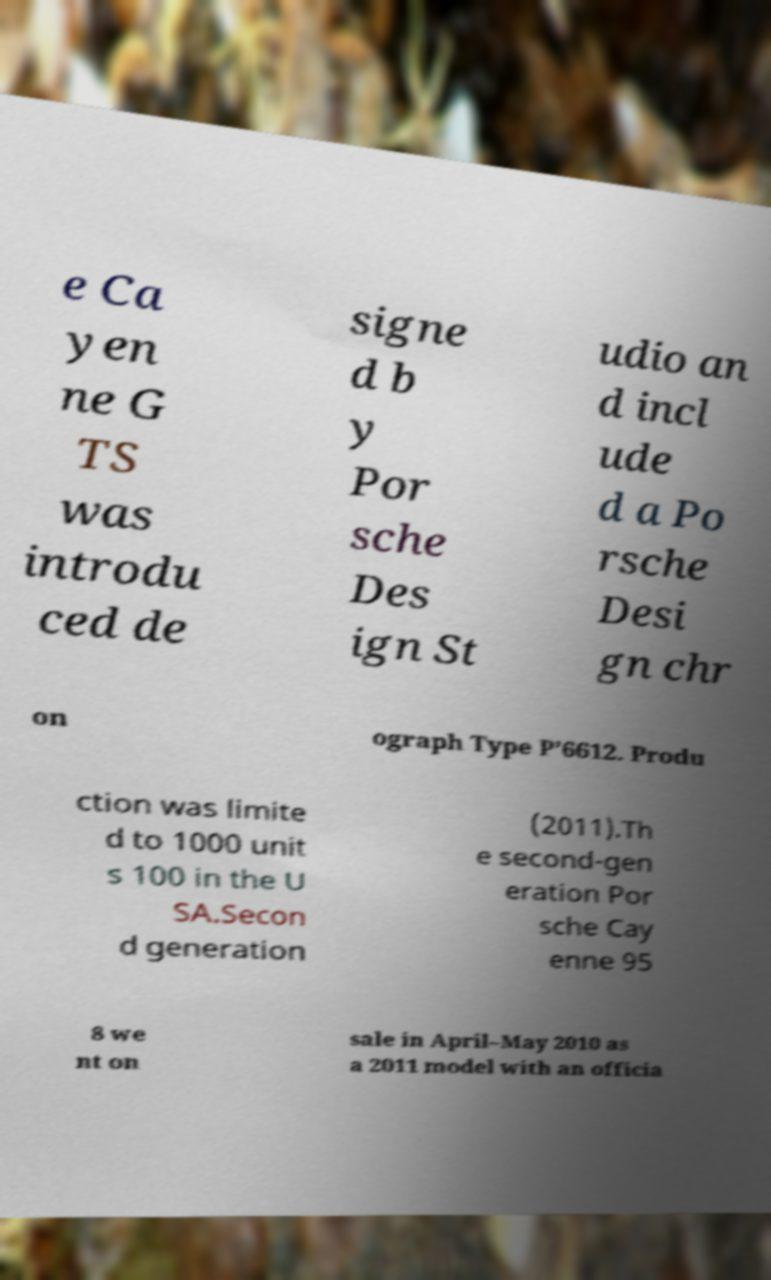Can you accurately transcribe the text from the provided image for me? e Ca yen ne G TS was introdu ced de signe d b y Por sche Des ign St udio an d incl ude d a Po rsche Desi gn chr on ograph Type P’6612. Produ ction was limite d to 1000 unit s 100 in the U SA.Secon d generation (2011).Th e second-gen eration Por sche Cay enne 95 8 we nt on sale in April–May 2010 as a 2011 model with an officia 